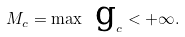Convert formula to latex. <formula><loc_0><loc_0><loc_500><loc_500>M _ { c } = \max \text { g} _ { c } < + \infty .</formula> 